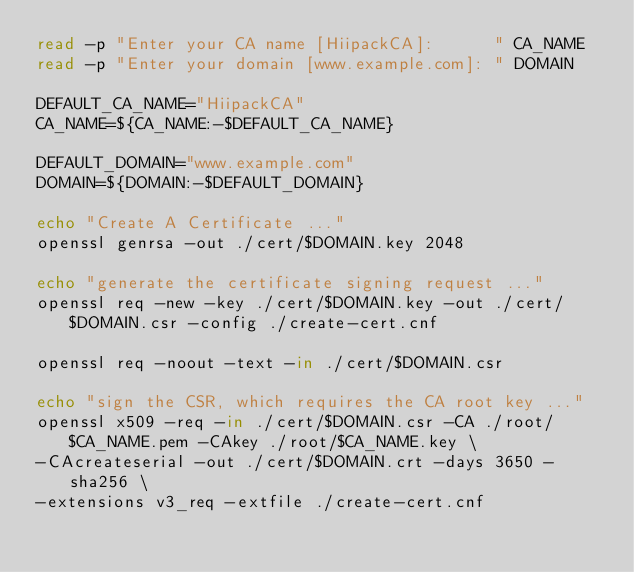<code> <loc_0><loc_0><loc_500><loc_500><_Bash_>read -p "Enter your CA name [HiipackCA]:      " CA_NAME
read -p "Enter your domain [www.example.com]: " DOMAIN

DEFAULT_CA_NAME="HiipackCA"
CA_NAME=${CA_NAME:-$DEFAULT_CA_NAME}

DEFAULT_DOMAIN="www.example.com"
DOMAIN=${DOMAIN:-$DEFAULT_DOMAIN}

echo "Create A Certificate ..."
openssl genrsa -out ./cert/$DOMAIN.key 2048

echo "generate the certificate signing request ..."
openssl req -new -key ./cert/$DOMAIN.key -out ./cert/$DOMAIN.csr -config ./create-cert.cnf

openssl req -noout -text -in ./cert/$DOMAIN.csr

echo "sign the CSR, which requires the CA root key ..."
openssl x509 -req -in ./cert/$DOMAIN.csr -CA ./root/$CA_NAME.pem -CAkey ./root/$CA_NAME.key \
-CAcreateserial -out ./cert/$DOMAIN.crt -days 3650 -sha256 \
-extensions v3_req -extfile ./create-cert.cnf</code> 